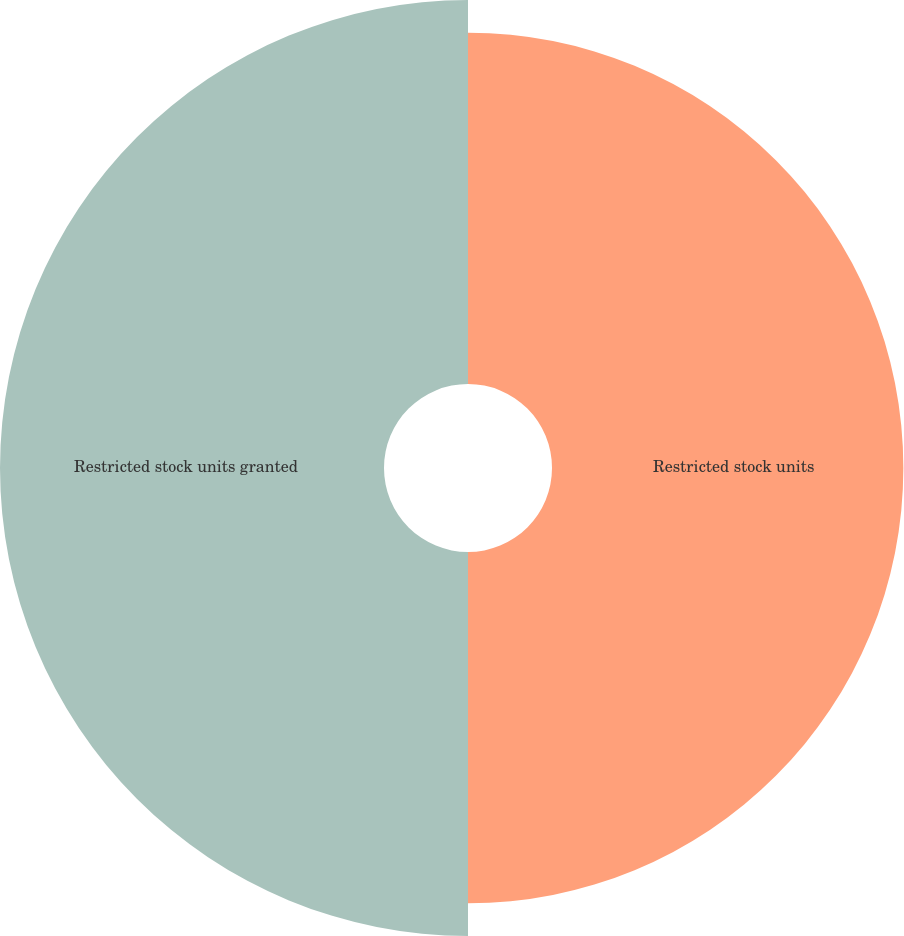<chart> <loc_0><loc_0><loc_500><loc_500><pie_chart><fcel>Restricted stock units<fcel>Restricted stock units granted<nl><fcel>47.78%<fcel>52.22%<nl></chart> 